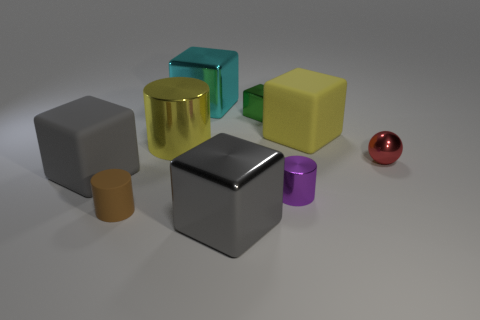Is the color of the large metallic cylinder the same as the large rubber thing right of the tiny brown rubber cylinder?
Make the answer very short. Yes. What size is the other gray thing that is the same shape as the big gray metal thing?
Provide a succinct answer. Large. There is a small metallic thing that is the same shape as the brown matte thing; what color is it?
Ensure brevity in your answer.  Purple. There is a object behind the green thing; does it have the same size as the cylinder that is to the right of the small green thing?
Give a very brief answer. No. Is there a big gray shiny object that has the same shape as the cyan metal thing?
Give a very brief answer. Yes. There is a object that is the same color as the large metal cylinder; what shape is it?
Give a very brief answer. Cube. Are there any matte objects of the same color as the big cylinder?
Provide a short and direct response. Yes. There is a red ball that is the same material as the cyan thing; what is its size?
Provide a short and direct response. Small. There is a large gray object that is in front of the purple shiny cylinder; does it have the same shape as the green metal thing?
Make the answer very short. Yes. How many objects are either large purple rubber cylinders or rubber things that are left of the big yellow rubber cube?
Your answer should be very brief. 2. 